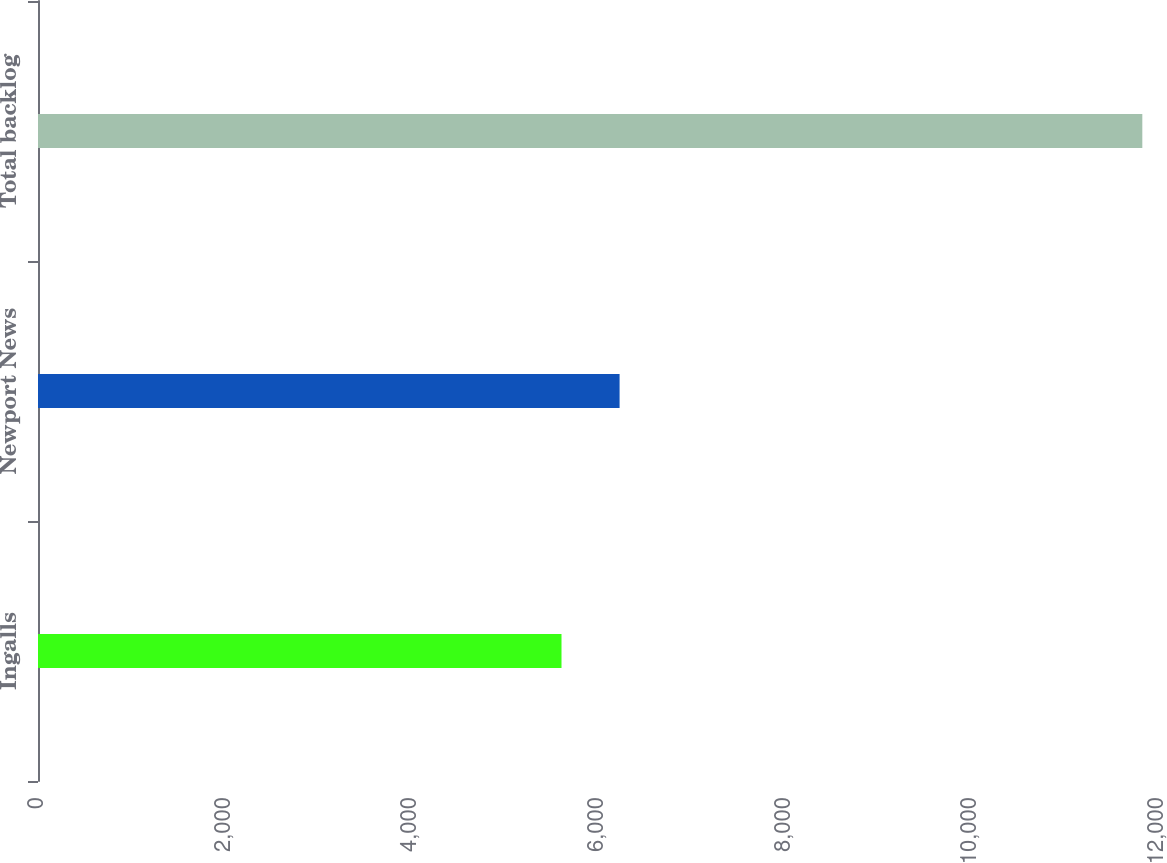Convert chart. <chart><loc_0><loc_0><loc_500><loc_500><bar_chart><fcel>Ingalls<fcel>Newport News<fcel>Total backlog<nl><fcel>5609<fcel>6231.3<fcel>11832<nl></chart> 